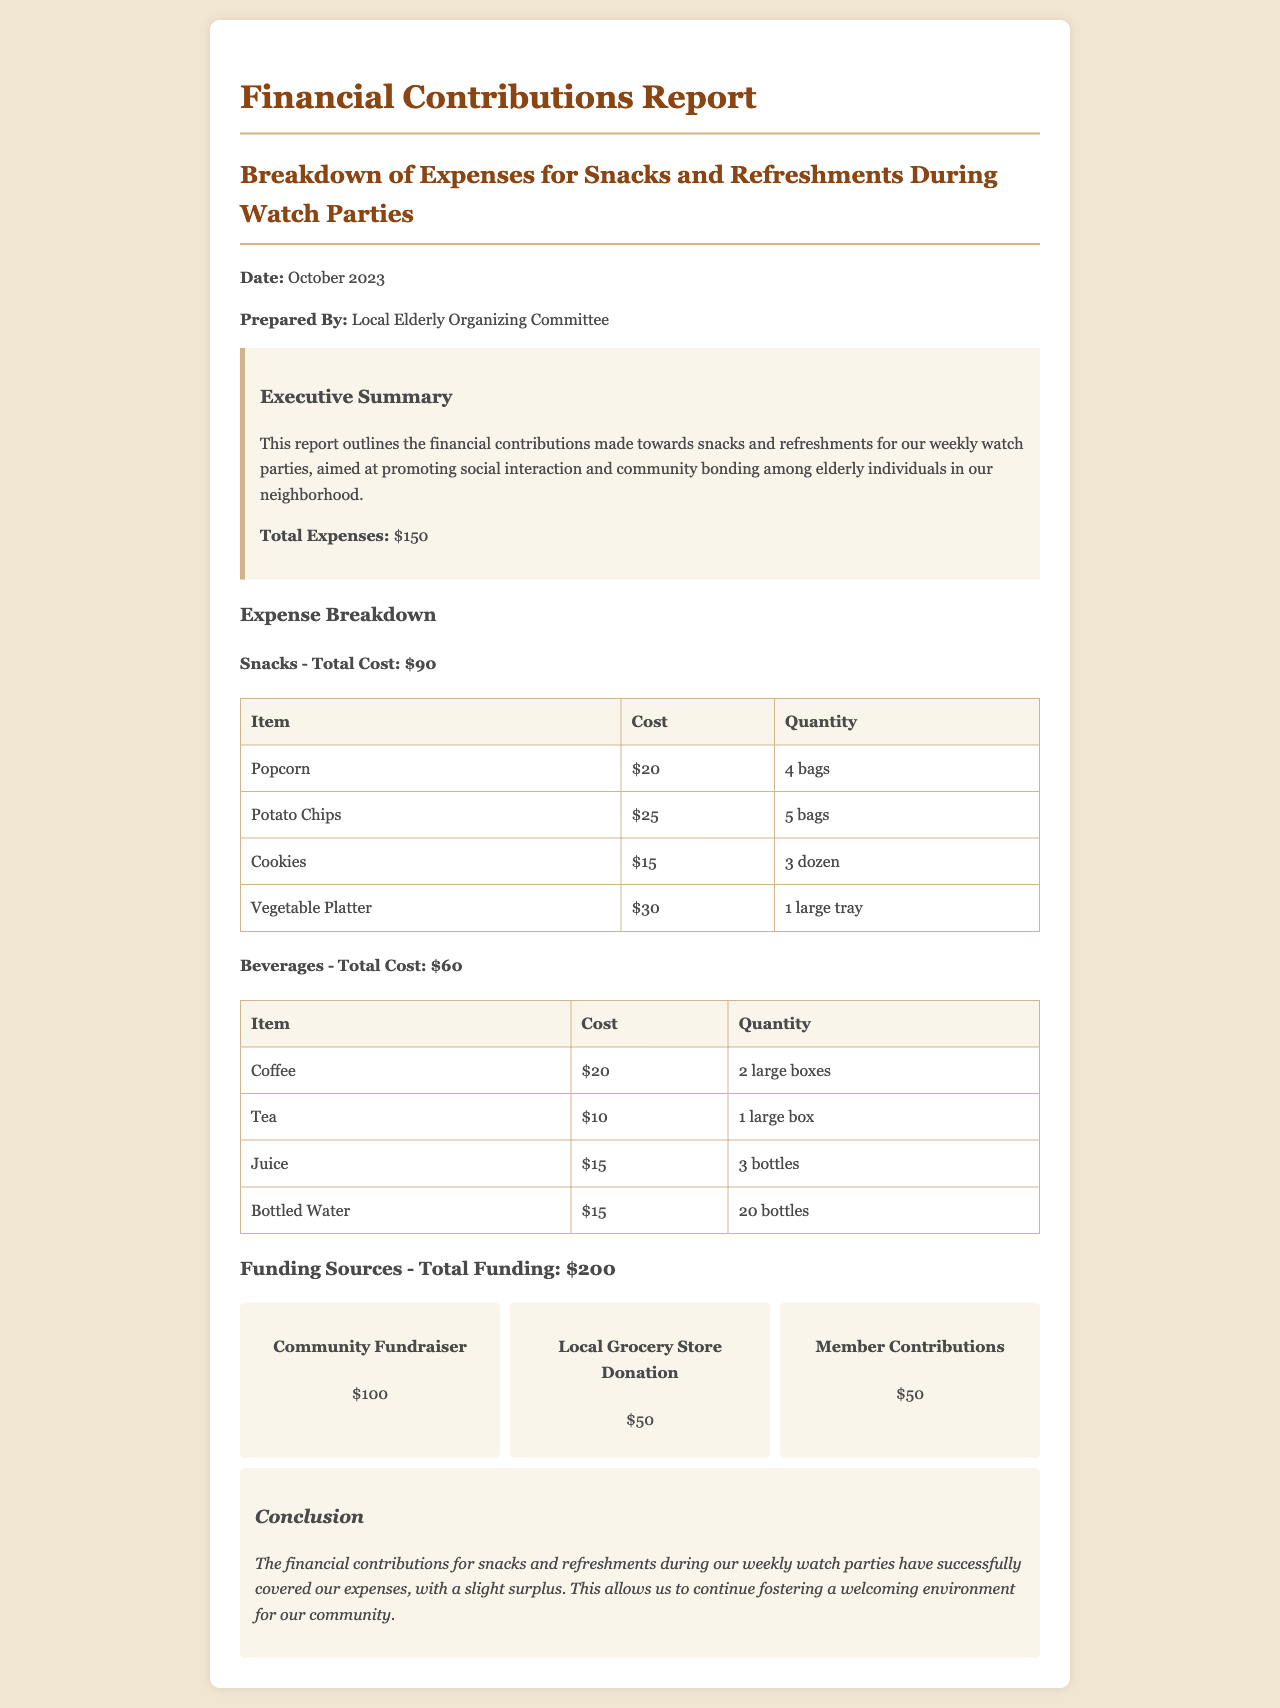What is the total cost of snacks? The total cost of snacks is provided in the expense breakdown section, which is $90.
Answer: $90 What is the total cost of beverages? The total cost of beverages is outlined in the document, which is $60.
Answer: $60 How many bags of potato chips were purchased? The quantity of potato chips is listed in the snacks table as 5 bags.
Answer: 5 bags What is the total funding received? The total funding amount is specified in the funding sources section, which is $200.
Answer: $200 What is the item with the highest cost in snacks? The document shows that the vegetable platter has the highest cost in snacks, which is $30.
Answer: Vegetable Platter How much did the local grocery store donate? The local grocery store's donation amount is stated in the funding sources, which is $50.
Answer: $50 What was the purpose of the financial contributions? The purpose is explained in the executive summary as promoting social interaction and community bonding among elderly individuals.
Answer: Promoting social interaction What is the surplus amount after expenses? The surplus is calculated by subtracting total expenses from total funding: $200 - $150 = $50.
Answer: $50 How many bottles of water were provided? The quantity of bottled water is detailed in the beverages table, which is 20 bottles.
Answer: 20 bottles 